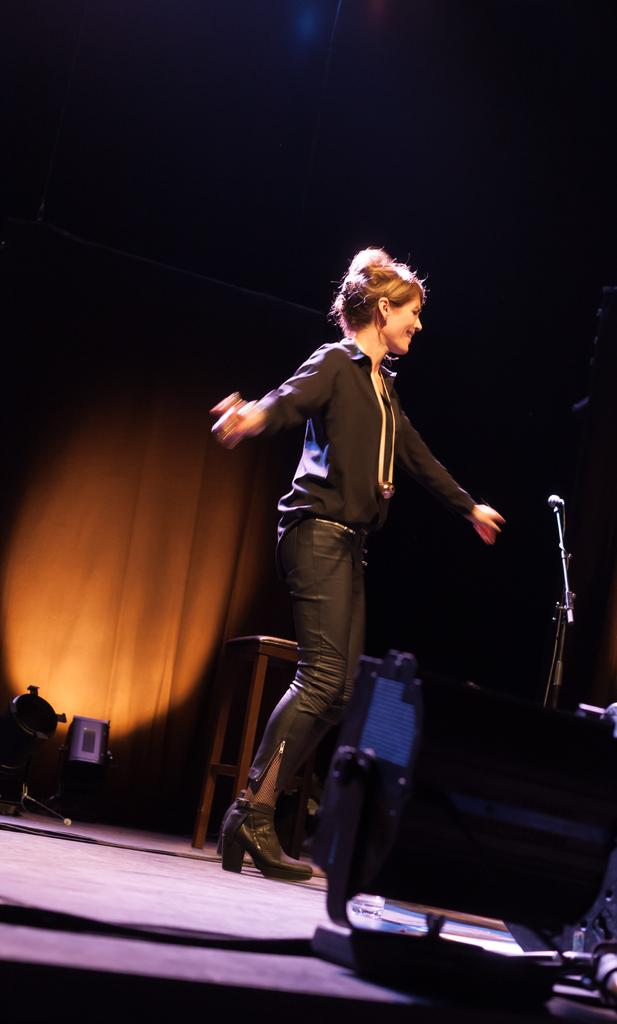What is the person in the image doing? There is a person standing in the image, but their activity is not specified. What is the person wearing in the image? The person is wearing a black dress. What can be seen near the person in the image? There is a mic stand in the image. What is present in the image besides the person and the mic stand? There is a table in the image, and there are objects on the table's surface. How would you describe the background of the image? The background of the image is in brown and black colors. How does the person in the image control the copy? There is no mention of copy or control in the image. The image only shows a person standing, wearing a black dress, with a mic stand nearby, a table with objects on its surface, and a background in brown and black colors. 